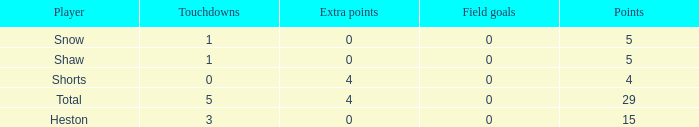Parse the table in full. {'header': ['Player', 'Touchdowns', 'Extra points', 'Field goals', 'Points'], 'rows': [['Snow', '1', '0', '0', '5'], ['Shaw', '1', '0', '0', '5'], ['Shorts', '0', '4', '0', '4'], ['Total', '5', '4', '0', '29'], ['Heston', '3', '0', '0', '15']]} What is the sum of all the touchdowns when the player had more than 0 extra points and less than 0 field goals? None. 